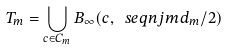Convert formula to latex. <formula><loc_0><loc_0><loc_500><loc_500>T _ { m } = \bigcup _ { c \in C _ { m } } B _ { \infty } ( c , \ s e q n { j } { m } d _ { m } / 2 )</formula> 